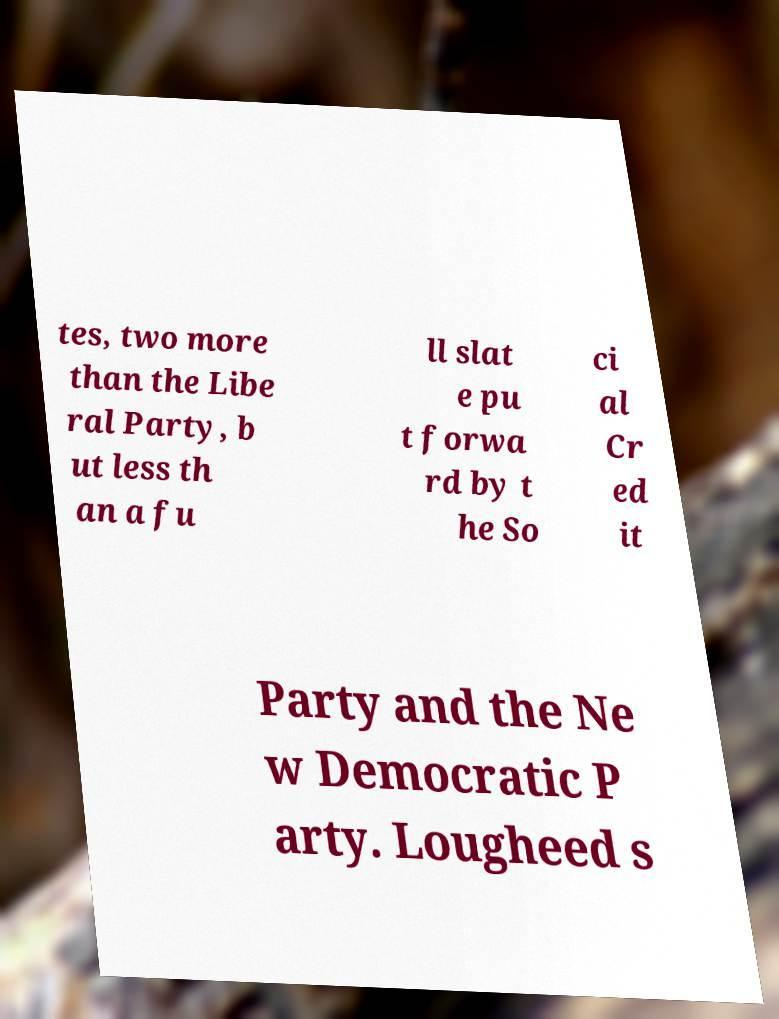Can you read and provide the text displayed in the image?This photo seems to have some interesting text. Can you extract and type it out for me? tes, two more than the Libe ral Party, b ut less th an a fu ll slat e pu t forwa rd by t he So ci al Cr ed it Party and the Ne w Democratic P arty. Lougheed s 